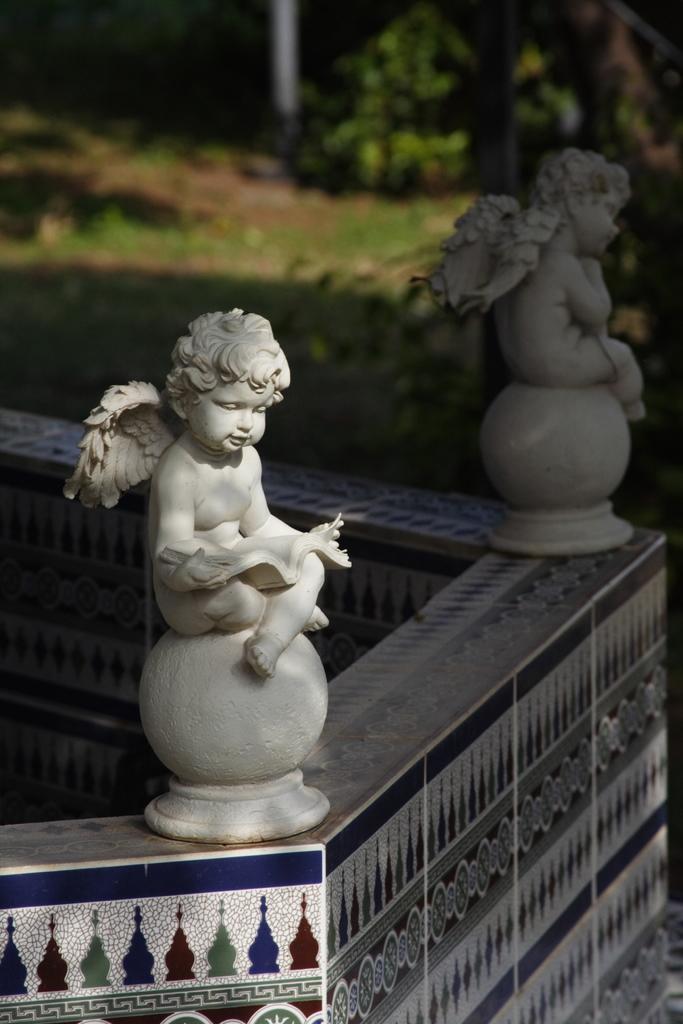Can you describe this image briefly? In this picture we can see there are two figures on the path and behind the figurines there is a blurred background. 